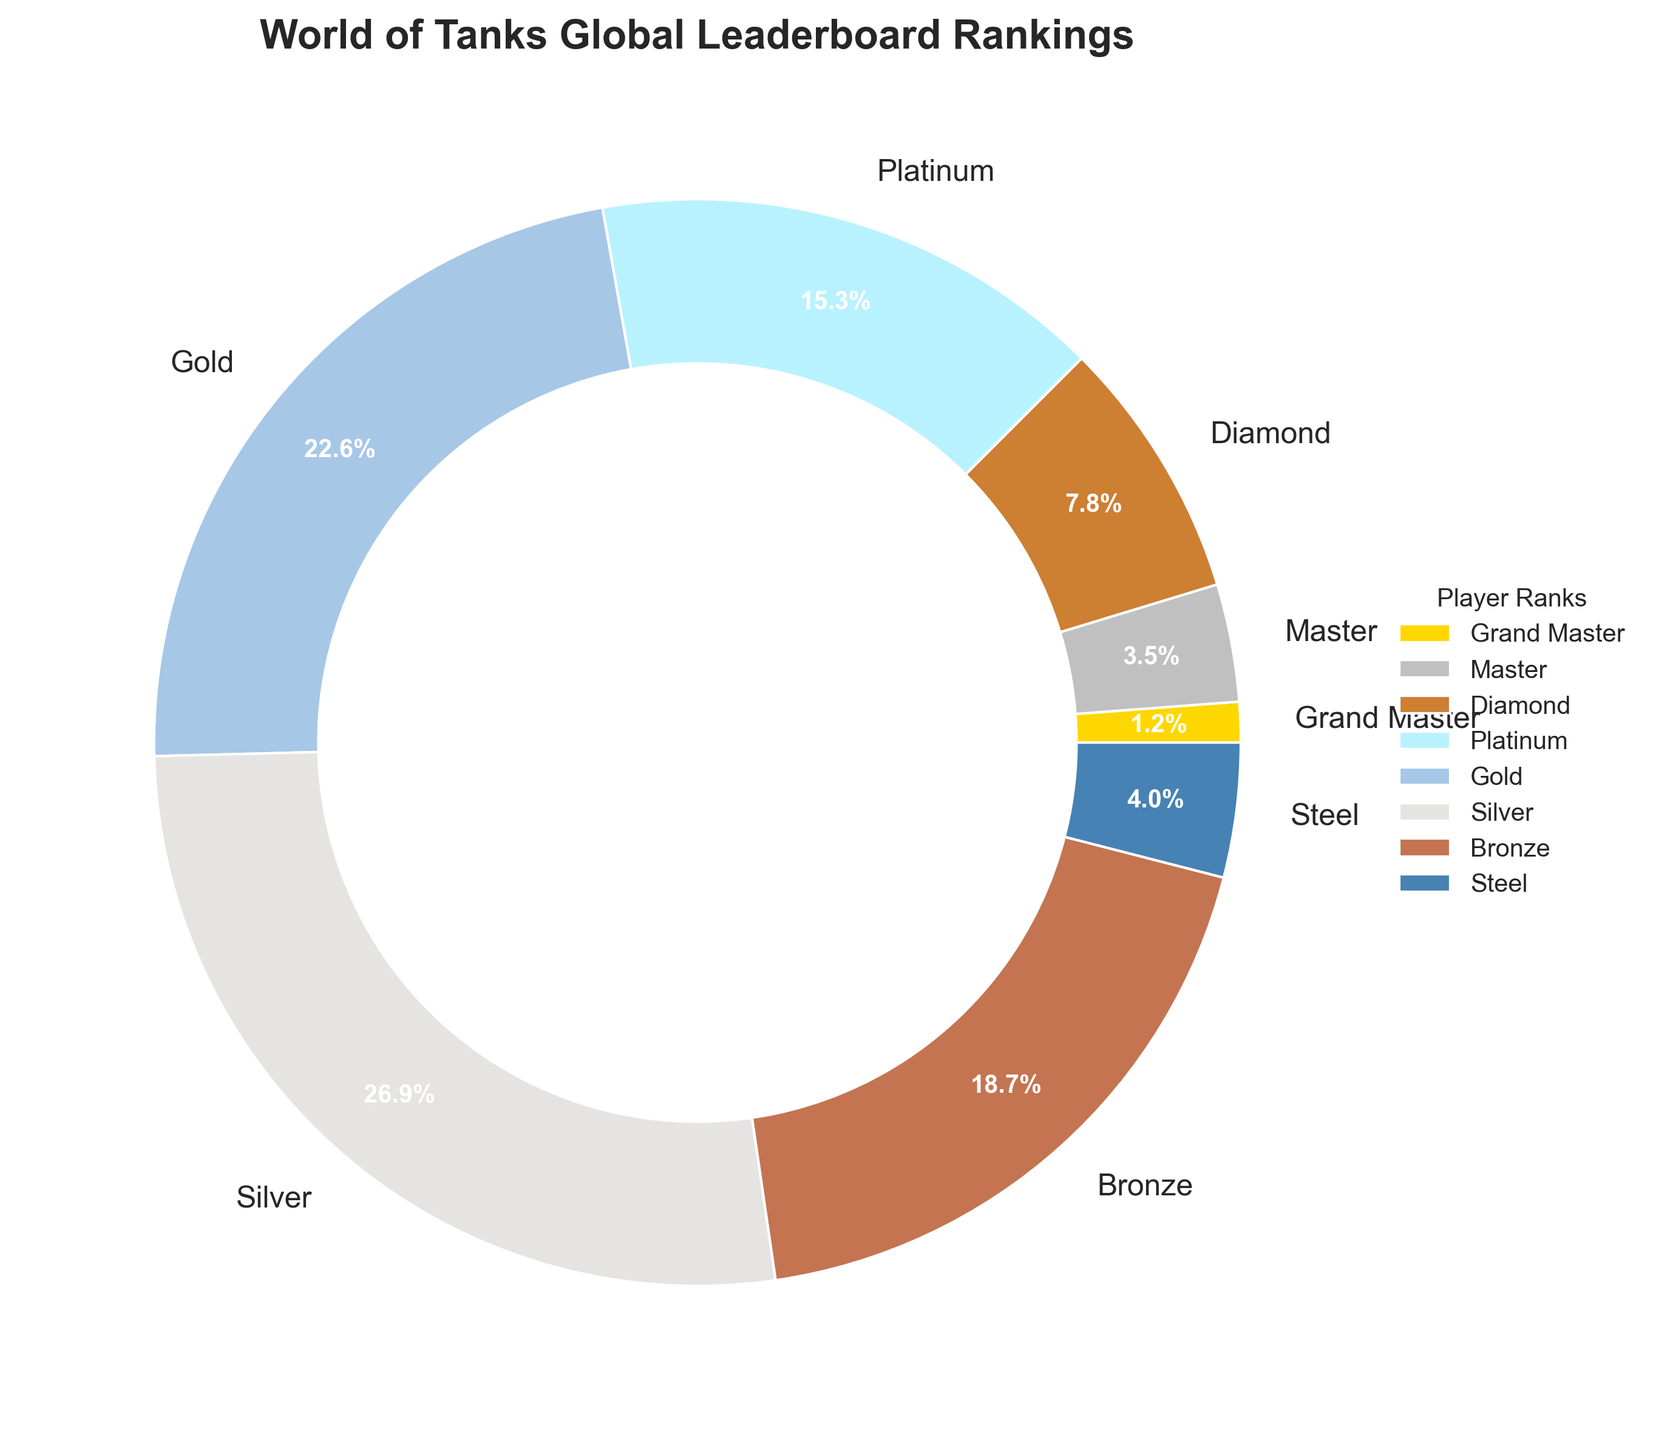What's the smallest rank percentage shown in the chart? The smallest rank percentage shown in the chart is identified by looking at the pie chart and finding the smallest wedge. The smallest percentage shown is for Grand Master, which is 1.2%.
Answer: 1.2% What is the combined percentage of the Master and Diamond ranks? To find the combined percentage of the Master and Diamond ranks, add their individual percentages. The percentage for Master is 3.5% and for Diamond is 7.8%, so the combined percentage is 3.5% + 7.8% = 11.3%.
Answer: 11.3% Which rank has a higher percentage, Silver or Gold? By comparing the wedge sizes and labels for Silver and Gold in the pie chart, it is clear that the percentage for Silver is 26.9% while Gold is 22.6%. Therefore, Silver has a higher percentage.
Answer: Silver What is the percentage difference between the Platinum and Bronze ranks? The percentage for Platinum is 15.3% and for Bronze is 18.7%. To find the difference, subtract the smaller percentage from the larger one: 18.7% - 15.3% = 3.4%.
Answer: 3.4% What is the total percentage of players in Gold, Silver, and Bronze ranks combined? To find the total percentage of players in Gold, Silver, and Bronze ranks, add their individual percentages: Gold (22.6%) + Silver (26.9%) + Bronze (18.7%). Therefore, the total percentage is 22.6% + 26.9% + 18.7% = 68.2%.
Answer: 68.2% Which rank's wedge is colored blue? By examining the pie chart and the custom colors used for the ranks, the rank colored blue is Platinum.
Answer: Platinum Are there more players in the Steel rank or the Grand Master rank? The percentage for Steel is 4.0% while the percentage for Grand Master is 1.2%. Thus, there are more players in the Steel rank.
Answer: Steel Out of the ranks Gold, Platinum, and Steel, which has the smallest percentage? By checking the percentages for Gold (22.6%), Platinum (15.3%), and Steel (4.0%) in the pie chart, the rank with the smallest percentage is Steel.
Answer: Steel 